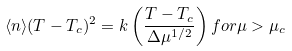<formula> <loc_0><loc_0><loc_500><loc_500>\langle n \rangle ( T - T _ { c } ) ^ { 2 } = k \left ( \frac { T - T _ { c } } { \Delta \mu ^ { 1 / 2 } } \right ) f o r \mu > \mu _ { c }</formula> 